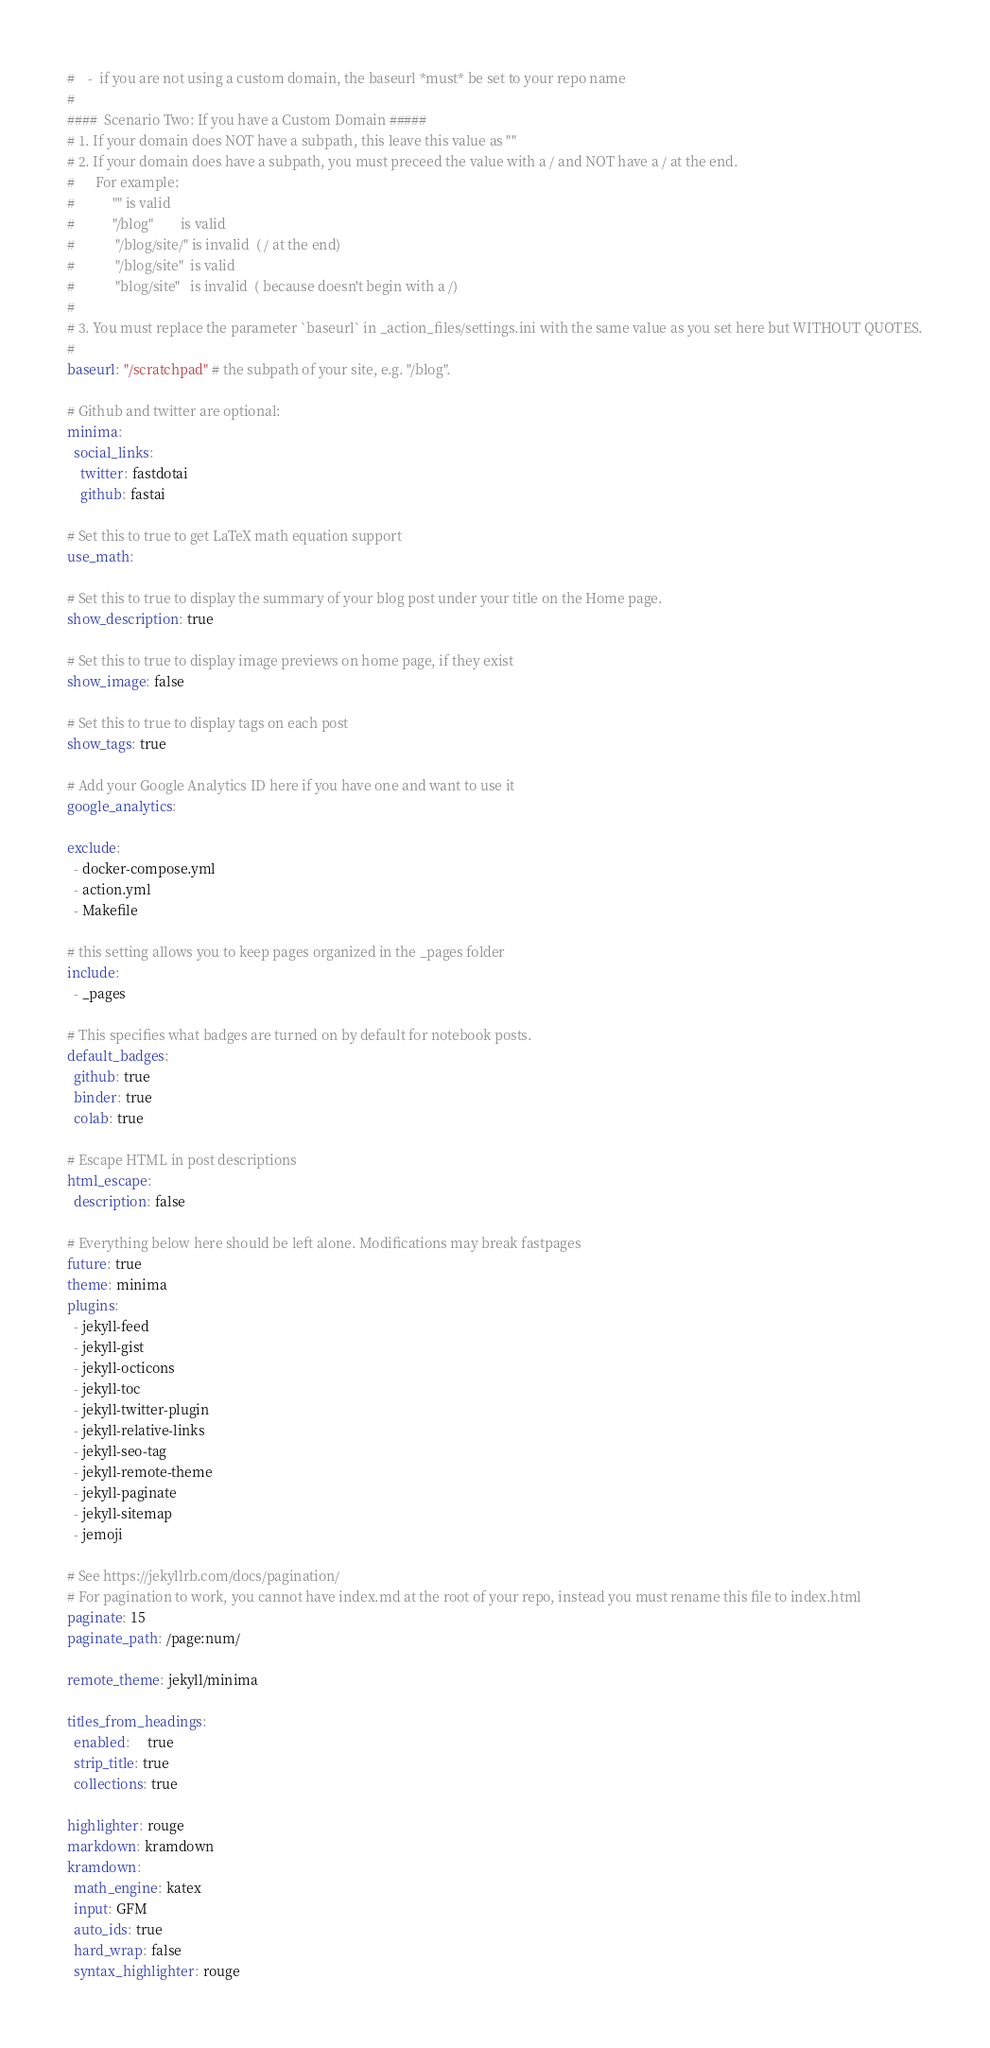<code> <loc_0><loc_0><loc_500><loc_500><_YAML_>#    -  if you are not using a custom domain, the baseurl *must* be set to your repo name
# 
####  Scenario Two: If you have a Custom Domain #####
# 1. If your domain does NOT have a subpath, this leave this value as ""
# 2. If your domain does have a subpath, you must preceed the value with a / and NOT have a / at the end.  
#      For example: 
#           "" is valid
#           "/blog"        is valid
#            "/blog/site/" is invalid  ( / at the end)
#            "/blog/site"  is valid
#            "blog/site"   is invalid  ( because doesn't begin with a /)
#
# 3. You must replace the parameter `baseurl` in _action_files/settings.ini with the same value as you set here but WITHOUT QUOTES.
#
baseurl: "/scratchpad" # the subpath of your site, e.g. "/blog".

# Github and twitter are optional:
minima:
  social_links:
    twitter: fastdotai
    github: fastai

# Set this to true to get LaTeX math equation support
use_math: 

# Set this to true to display the summary of your blog post under your title on the Home page.
show_description: true

# Set this to true to display image previews on home page, if they exist
show_image: false

# Set this to true to display tags on each post
show_tags: true

# Add your Google Analytics ID here if you have one and want to use it
google_analytics: 

exclude:
  - docker-compose.yml
  - action.yml
  - Makefile

# this setting allows you to keep pages organized in the _pages folder
include:
  - _pages

# This specifies what badges are turned on by default for notebook posts.
default_badges:
  github: true
  binder: true
  colab: true

# Escape HTML in post descriptions
html_escape:
  description: false

# Everything below here should be left alone. Modifications may break fastpages
future: true
theme: minima
plugins:
  - jekyll-feed
  - jekyll-gist
  - jekyll-octicons
  - jekyll-toc
  - jekyll-twitter-plugin
  - jekyll-relative-links
  - jekyll-seo-tag
  - jekyll-remote-theme
  - jekyll-paginate
  - jekyll-sitemap
  - jemoji

# See https://jekyllrb.com/docs/pagination/
# For pagination to work, you cannot have index.md at the root of your repo, instead you must rename this file to index.html
paginate: 15
paginate_path: /page:num/

remote_theme: jekyll/minima

titles_from_headings:
  enabled:     true
  strip_title: true
  collections: true

highlighter: rouge
markdown: kramdown
kramdown:
  math_engine: katex
  input: GFM
  auto_ids: true
  hard_wrap: false
  syntax_highlighter: rouge
</code> 